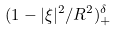Convert formula to latex. <formula><loc_0><loc_0><loc_500><loc_500>( 1 - | \xi | ^ { 2 } / R ^ { 2 } ) _ { + } ^ { \delta }</formula> 